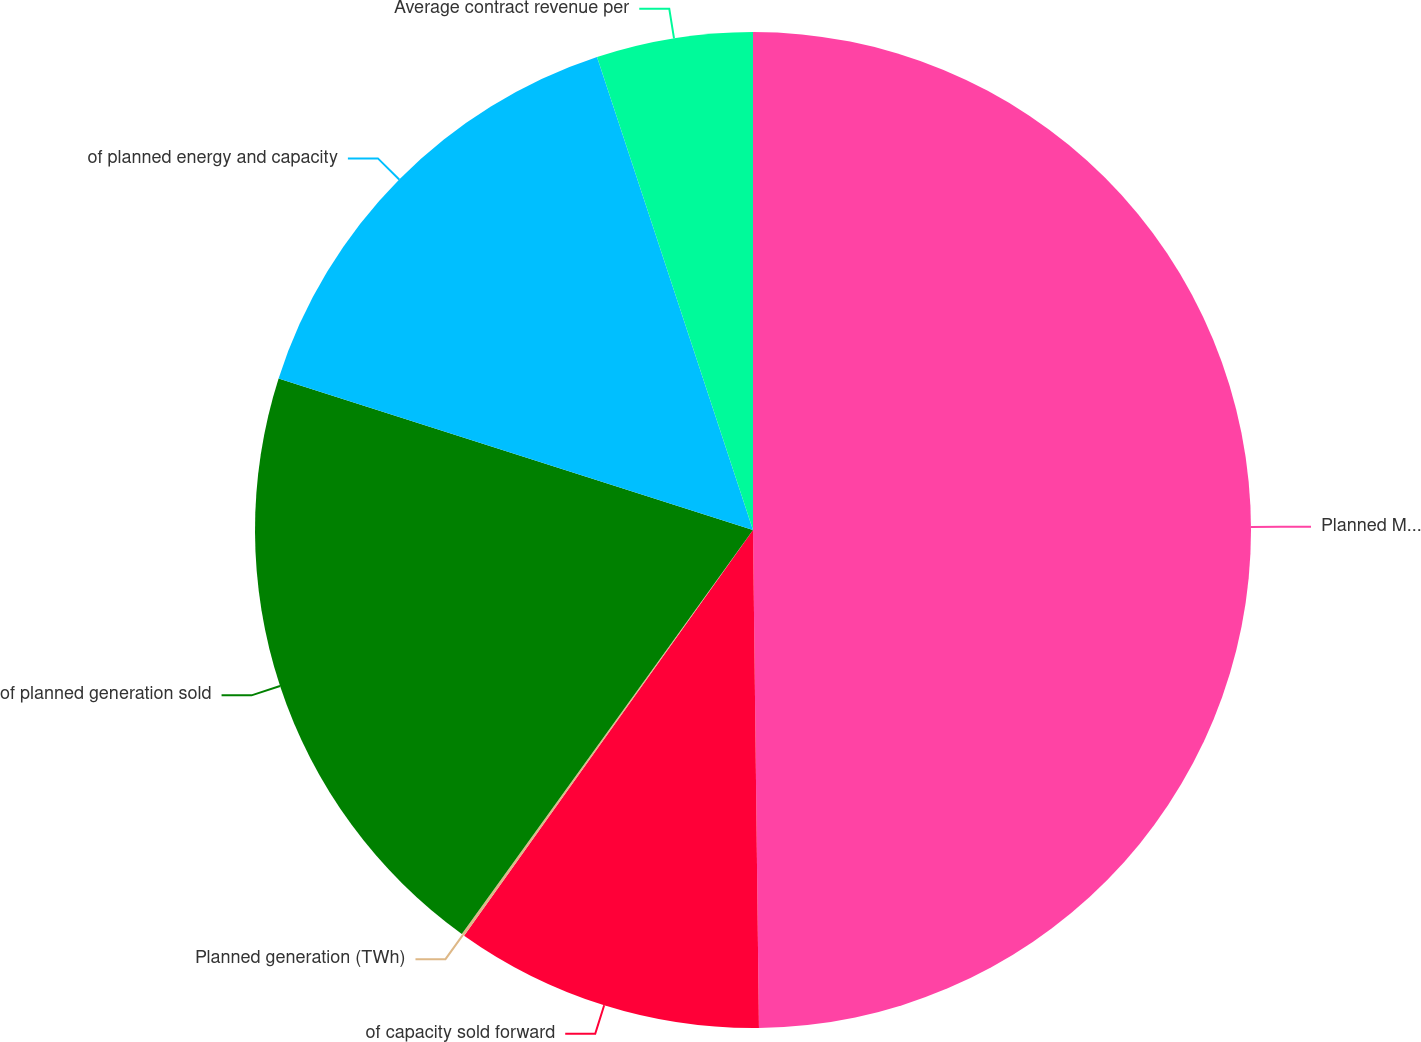Convert chart. <chart><loc_0><loc_0><loc_500><loc_500><pie_chart><fcel>Planned MW in operation<fcel>of capacity sold forward<fcel>Planned generation (TWh)<fcel>of planned generation sold<fcel>of planned energy and capacity<fcel>Average contract revenue per<nl><fcel>49.81%<fcel>10.04%<fcel>0.09%<fcel>19.98%<fcel>15.01%<fcel>5.07%<nl></chart> 